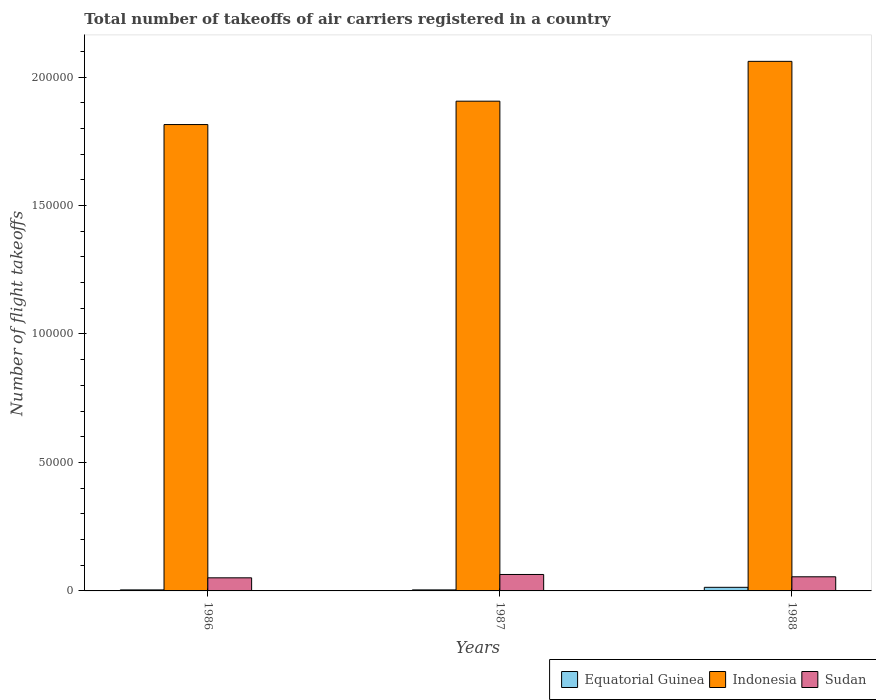How many different coloured bars are there?
Ensure brevity in your answer.  3. How many groups of bars are there?
Keep it short and to the point. 3. Are the number of bars on each tick of the X-axis equal?
Keep it short and to the point. Yes. How many bars are there on the 3rd tick from the left?
Your answer should be compact. 3. What is the label of the 1st group of bars from the left?
Make the answer very short. 1986. In how many cases, is the number of bars for a given year not equal to the number of legend labels?
Provide a short and direct response. 0. What is the total number of flight takeoffs in Sudan in 1987?
Offer a terse response. 6400. Across all years, what is the maximum total number of flight takeoffs in Sudan?
Keep it short and to the point. 6400. Across all years, what is the minimum total number of flight takeoffs in Equatorial Guinea?
Your answer should be very brief. 400. In which year was the total number of flight takeoffs in Equatorial Guinea minimum?
Offer a terse response. 1986. What is the total total number of flight takeoffs in Sudan in the graph?
Make the answer very short. 1.70e+04. What is the difference between the total number of flight takeoffs in Sudan in 1986 and that in 1987?
Offer a terse response. -1300. What is the difference between the total number of flight takeoffs in Sudan in 1986 and the total number of flight takeoffs in Equatorial Guinea in 1987?
Your response must be concise. 4700. What is the average total number of flight takeoffs in Sudan per year?
Ensure brevity in your answer.  5666.67. In the year 1988, what is the difference between the total number of flight takeoffs in Indonesia and total number of flight takeoffs in Sudan?
Offer a very short reply. 2.01e+05. In how many years, is the total number of flight takeoffs in Equatorial Guinea greater than 110000?
Your answer should be very brief. 0. What is the ratio of the total number of flight takeoffs in Equatorial Guinea in 1987 to that in 1988?
Offer a very short reply. 0.29. Is the total number of flight takeoffs in Sudan in 1986 less than that in 1988?
Provide a succinct answer. Yes. What is the difference between the highest and the second highest total number of flight takeoffs in Indonesia?
Ensure brevity in your answer.  1.55e+04. What is the difference between the highest and the lowest total number of flight takeoffs in Sudan?
Your answer should be compact. 1300. Is the sum of the total number of flight takeoffs in Indonesia in 1986 and 1987 greater than the maximum total number of flight takeoffs in Sudan across all years?
Ensure brevity in your answer.  Yes. What does the 3rd bar from the left in 1987 represents?
Give a very brief answer. Sudan. What does the 1st bar from the right in 1986 represents?
Provide a succinct answer. Sudan. Are all the bars in the graph horizontal?
Make the answer very short. No. Are the values on the major ticks of Y-axis written in scientific E-notation?
Offer a terse response. No. Does the graph contain grids?
Offer a terse response. No. How are the legend labels stacked?
Give a very brief answer. Horizontal. What is the title of the graph?
Offer a very short reply. Total number of takeoffs of air carriers registered in a country. What is the label or title of the Y-axis?
Provide a succinct answer. Number of flight takeoffs. What is the Number of flight takeoffs in Indonesia in 1986?
Offer a terse response. 1.82e+05. What is the Number of flight takeoffs in Sudan in 1986?
Your answer should be very brief. 5100. What is the Number of flight takeoffs of Equatorial Guinea in 1987?
Offer a terse response. 400. What is the Number of flight takeoffs in Indonesia in 1987?
Provide a short and direct response. 1.91e+05. What is the Number of flight takeoffs of Sudan in 1987?
Offer a very short reply. 6400. What is the Number of flight takeoffs in Equatorial Guinea in 1988?
Ensure brevity in your answer.  1400. What is the Number of flight takeoffs in Indonesia in 1988?
Ensure brevity in your answer.  2.06e+05. What is the Number of flight takeoffs in Sudan in 1988?
Provide a short and direct response. 5500. Across all years, what is the maximum Number of flight takeoffs of Equatorial Guinea?
Offer a terse response. 1400. Across all years, what is the maximum Number of flight takeoffs in Indonesia?
Offer a very short reply. 2.06e+05. Across all years, what is the maximum Number of flight takeoffs of Sudan?
Offer a terse response. 6400. Across all years, what is the minimum Number of flight takeoffs of Indonesia?
Your answer should be compact. 1.82e+05. Across all years, what is the minimum Number of flight takeoffs of Sudan?
Make the answer very short. 5100. What is the total Number of flight takeoffs of Equatorial Guinea in the graph?
Provide a short and direct response. 2200. What is the total Number of flight takeoffs of Indonesia in the graph?
Keep it short and to the point. 5.78e+05. What is the total Number of flight takeoffs in Sudan in the graph?
Offer a terse response. 1.70e+04. What is the difference between the Number of flight takeoffs in Indonesia in 1986 and that in 1987?
Ensure brevity in your answer.  -9100. What is the difference between the Number of flight takeoffs of Sudan in 1986 and that in 1987?
Ensure brevity in your answer.  -1300. What is the difference between the Number of flight takeoffs of Equatorial Guinea in 1986 and that in 1988?
Your answer should be compact. -1000. What is the difference between the Number of flight takeoffs in Indonesia in 1986 and that in 1988?
Ensure brevity in your answer.  -2.46e+04. What is the difference between the Number of flight takeoffs in Sudan in 1986 and that in 1988?
Provide a short and direct response. -400. What is the difference between the Number of flight takeoffs in Equatorial Guinea in 1987 and that in 1988?
Provide a succinct answer. -1000. What is the difference between the Number of flight takeoffs of Indonesia in 1987 and that in 1988?
Make the answer very short. -1.55e+04. What is the difference between the Number of flight takeoffs of Sudan in 1987 and that in 1988?
Your answer should be compact. 900. What is the difference between the Number of flight takeoffs in Equatorial Guinea in 1986 and the Number of flight takeoffs in Indonesia in 1987?
Give a very brief answer. -1.90e+05. What is the difference between the Number of flight takeoffs of Equatorial Guinea in 1986 and the Number of flight takeoffs of Sudan in 1987?
Your answer should be very brief. -6000. What is the difference between the Number of flight takeoffs in Indonesia in 1986 and the Number of flight takeoffs in Sudan in 1987?
Ensure brevity in your answer.  1.75e+05. What is the difference between the Number of flight takeoffs in Equatorial Guinea in 1986 and the Number of flight takeoffs in Indonesia in 1988?
Your answer should be compact. -2.06e+05. What is the difference between the Number of flight takeoffs of Equatorial Guinea in 1986 and the Number of flight takeoffs of Sudan in 1988?
Provide a succinct answer. -5100. What is the difference between the Number of flight takeoffs of Indonesia in 1986 and the Number of flight takeoffs of Sudan in 1988?
Your response must be concise. 1.76e+05. What is the difference between the Number of flight takeoffs in Equatorial Guinea in 1987 and the Number of flight takeoffs in Indonesia in 1988?
Ensure brevity in your answer.  -2.06e+05. What is the difference between the Number of flight takeoffs in Equatorial Guinea in 1987 and the Number of flight takeoffs in Sudan in 1988?
Make the answer very short. -5100. What is the difference between the Number of flight takeoffs in Indonesia in 1987 and the Number of flight takeoffs in Sudan in 1988?
Make the answer very short. 1.85e+05. What is the average Number of flight takeoffs of Equatorial Guinea per year?
Keep it short and to the point. 733.33. What is the average Number of flight takeoffs of Indonesia per year?
Make the answer very short. 1.93e+05. What is the average Number of flight takeoffs of Sudan per year?
Give a very brief answer. 5666.67. In the year 1986, what is the difference between the Number of flight takeoffs in Equatorial Guinea and Number of flight takeoffs in Indonesia?
Ensure brevity in your answer.  -1.81e+05. In the year 1986, what is the difference between the Number of flight takeoffs of Equatorial Guinea and Number of flight takeoffs of Sudan?
Keep it short and to the point. -4700. In the year 1986, what is the difference between the Number of flight takeoffs of Indonesia and Number of flight takeoffs of Sudan?
Your response must be concise. 1.76e+05. In the year 1987, what is the difference between the Number of flight takeoffs of Equatorial Guinea and Number of flight takeoffs of Indonesia?
Give a very brief answer. -1.90e+05. In the year 1987, what is the difference between the Number of flight takeoffs of Equatorial Guinea and Number of flight takeoffs of Sudan?
Give a very brief answer. -6000. In the year 1987, what is the difference between the Number of flight takeoffs of Indonesia and Number of flight takeoffs of Sudan?
Your answer should be very brief. 1.84e+05. In the year 1988, what is the difference between the Number of flight takeoffs in Equatorial Guinea and Number of flight takeoffs in Indonesia?
Make the answer very short. -2.05e+05. In the year 1988, what is the difference between the Number of flight takeoffs in Equatorial Guinea and Number of flight takeoffs in Sudan?
Offer a very short reply. -4100. In the year 1988, what is the difference between the Number of flight takeoffs in Indonesia and Number of flight takeoffs in Sudan?
Offer a terse response. 2.01e+05. What is the ratio of the Number of flight takeoffs in Indonesia in 1986 to that in 1987?
Your answer should be very brief. 0.95. What is the ratio of the Number of flight takeoffs in Sudan in 1986 to that in 1987?
Provide a short and direct response. 0.8. What is the ratio of the Number of flight takeoffs in Equatorial Guinea in 1986 to that in 1988?
Your answer should be very brief. 0.29. What is the ratio of the Number of flight takeoffs of Indonesia in 1986 to that in 1988?
Provide a succinct answer. 0.88. What is the ratio of the Number of flight takeoffs of Sudan in 1986 to that in 1988?
Your answer should be compact. 0.93. What is the ratio of the Number of flight takeoffs in Equatorial Guinea in 1987 to that in 1988?
Keep it short and to the point. 0.29. What is the ratio of the Number of flight takeoffs of Indonesia in 1987 to that in 1988?
Your answer should be compact. 0.92. What is the ratio of the Number of flight takeoffs in Sudan in 1987 to that in 1988?
Provide a short and direct response. 1.16. What is the difference between the highest and the second highest Number of flight takeoffs of Equatorial Guinea?
Your answer should be very brief. 1000. What is the difference between the highest and the second highest Number of flight takeoffs of Indonesia?
Give a very brief answer. 1.55e+04. What is the difference between the highest and the second highest Number of flight takeoffs of Sudan?
Keep it short and to the point. 900. What is the difference between the highest and the lowest Number of flight takeoffs of Equatorial Guinea?
Provide a short and direct response. 1000. What is the difference between the highest and the lowest Number of flight takeoffs in Indonesia?
Make the answer very short. 2.46e+04. What is the difference between the highest and the lowest Number of flight takeoffs in Sudan?
Offer a terse response. 1300. 